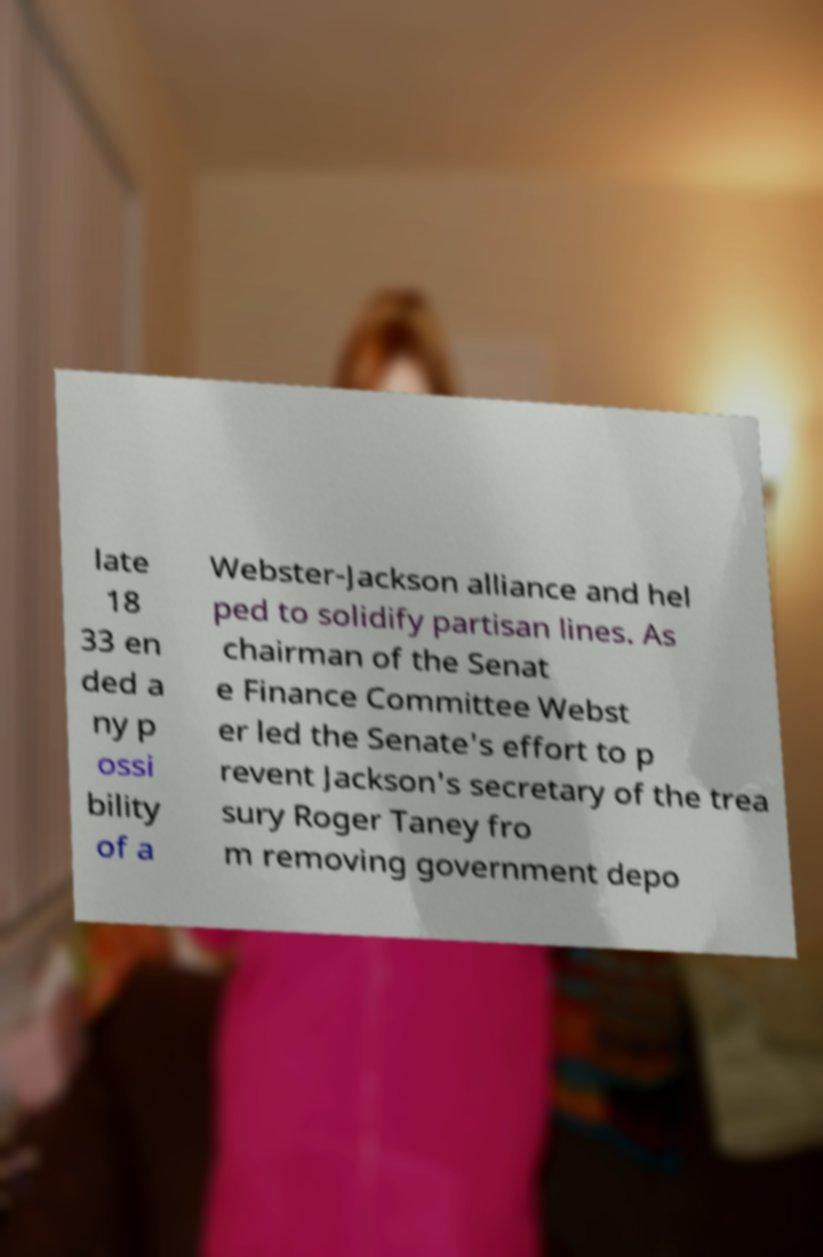Could you assist in decoding the text presented in this image and type it out clearly? late 18 33 en ded a ny p ossi bility of a Webster-Jackson alliance and hel ped to solidify partisan lines. As chairman of the Senat e Finance Committee Webst er led the Senate's effort to p revent Jackson's secretary of the trea sury Roger Taney fro m removing government depo 